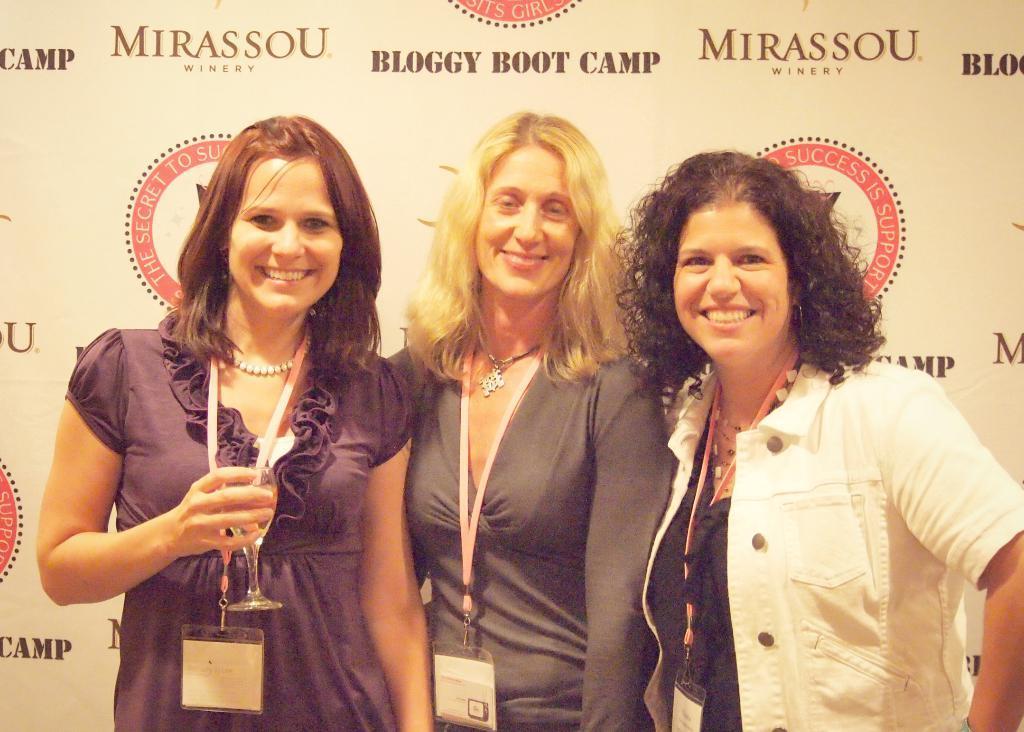How would you summarize this image in a sentence or two? In this image I can see three women wearing identity cards are standing and smiling. I can see a huge banner behind them. 